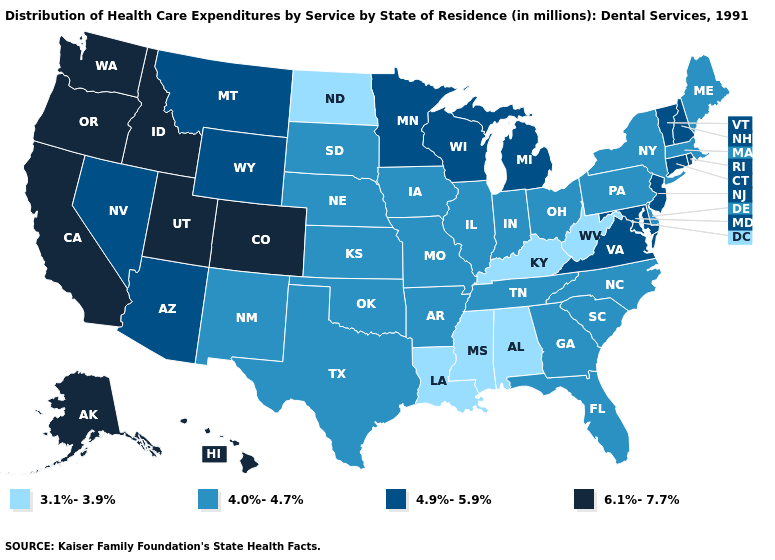Which states have the lowest value in the USA?
Short answer required. Alabama, Kentucky, Louisiana, Mississippi, North Dakota, West Virginia. Does the map have missing data?
Be succinct. No. Does the first symbol in the legend represent the smallest category?
Short answer required. Yes. Does Alaska have a lower value than Utah?
Quick response, please. No. Name the states that have a value in the range 4.9%-5.9%?
Answer briefly. Arizona, Connecticut, Maryland, Michigan, Minnesota, Montana, Nevada, New Hampshire, New Jersey, Rhode Island, Vermont, Virginia, Wisconsin, Wyoming. How many symbols are there in the legend?
Concise answer only. 4. What is the value of Kansas?
Quick response, please. 4.0%-4.7%. What is the value of Arkansas?
Be succinct. 4.0%-4.7%. Does the map have missing data?
Keep it brief. No. Does New Jersey have the highest value in the USA?
Give a very brief answer. No. Does Ohio have a higher value than Rhode Island?
Be succinct. No. What is the lowest value in the West?
Concise answer only. 4.0%-4.7%. Among the states that border Colorado , does Nebraska have the lowest value?
Give a very brief answer. Yes. Does the map have missing data?
Write a very short answer. No. Name the states that have a value in the range 4.9%-5.9%?
Give a very brief answer. Arizona, Connecticut, Maryland, Michigan, Minnesota, Montana, Nevada, New Hampshire, New Jersey, Rhode Island, Vermont, Virginia, Wisconsin, Wyoming. 